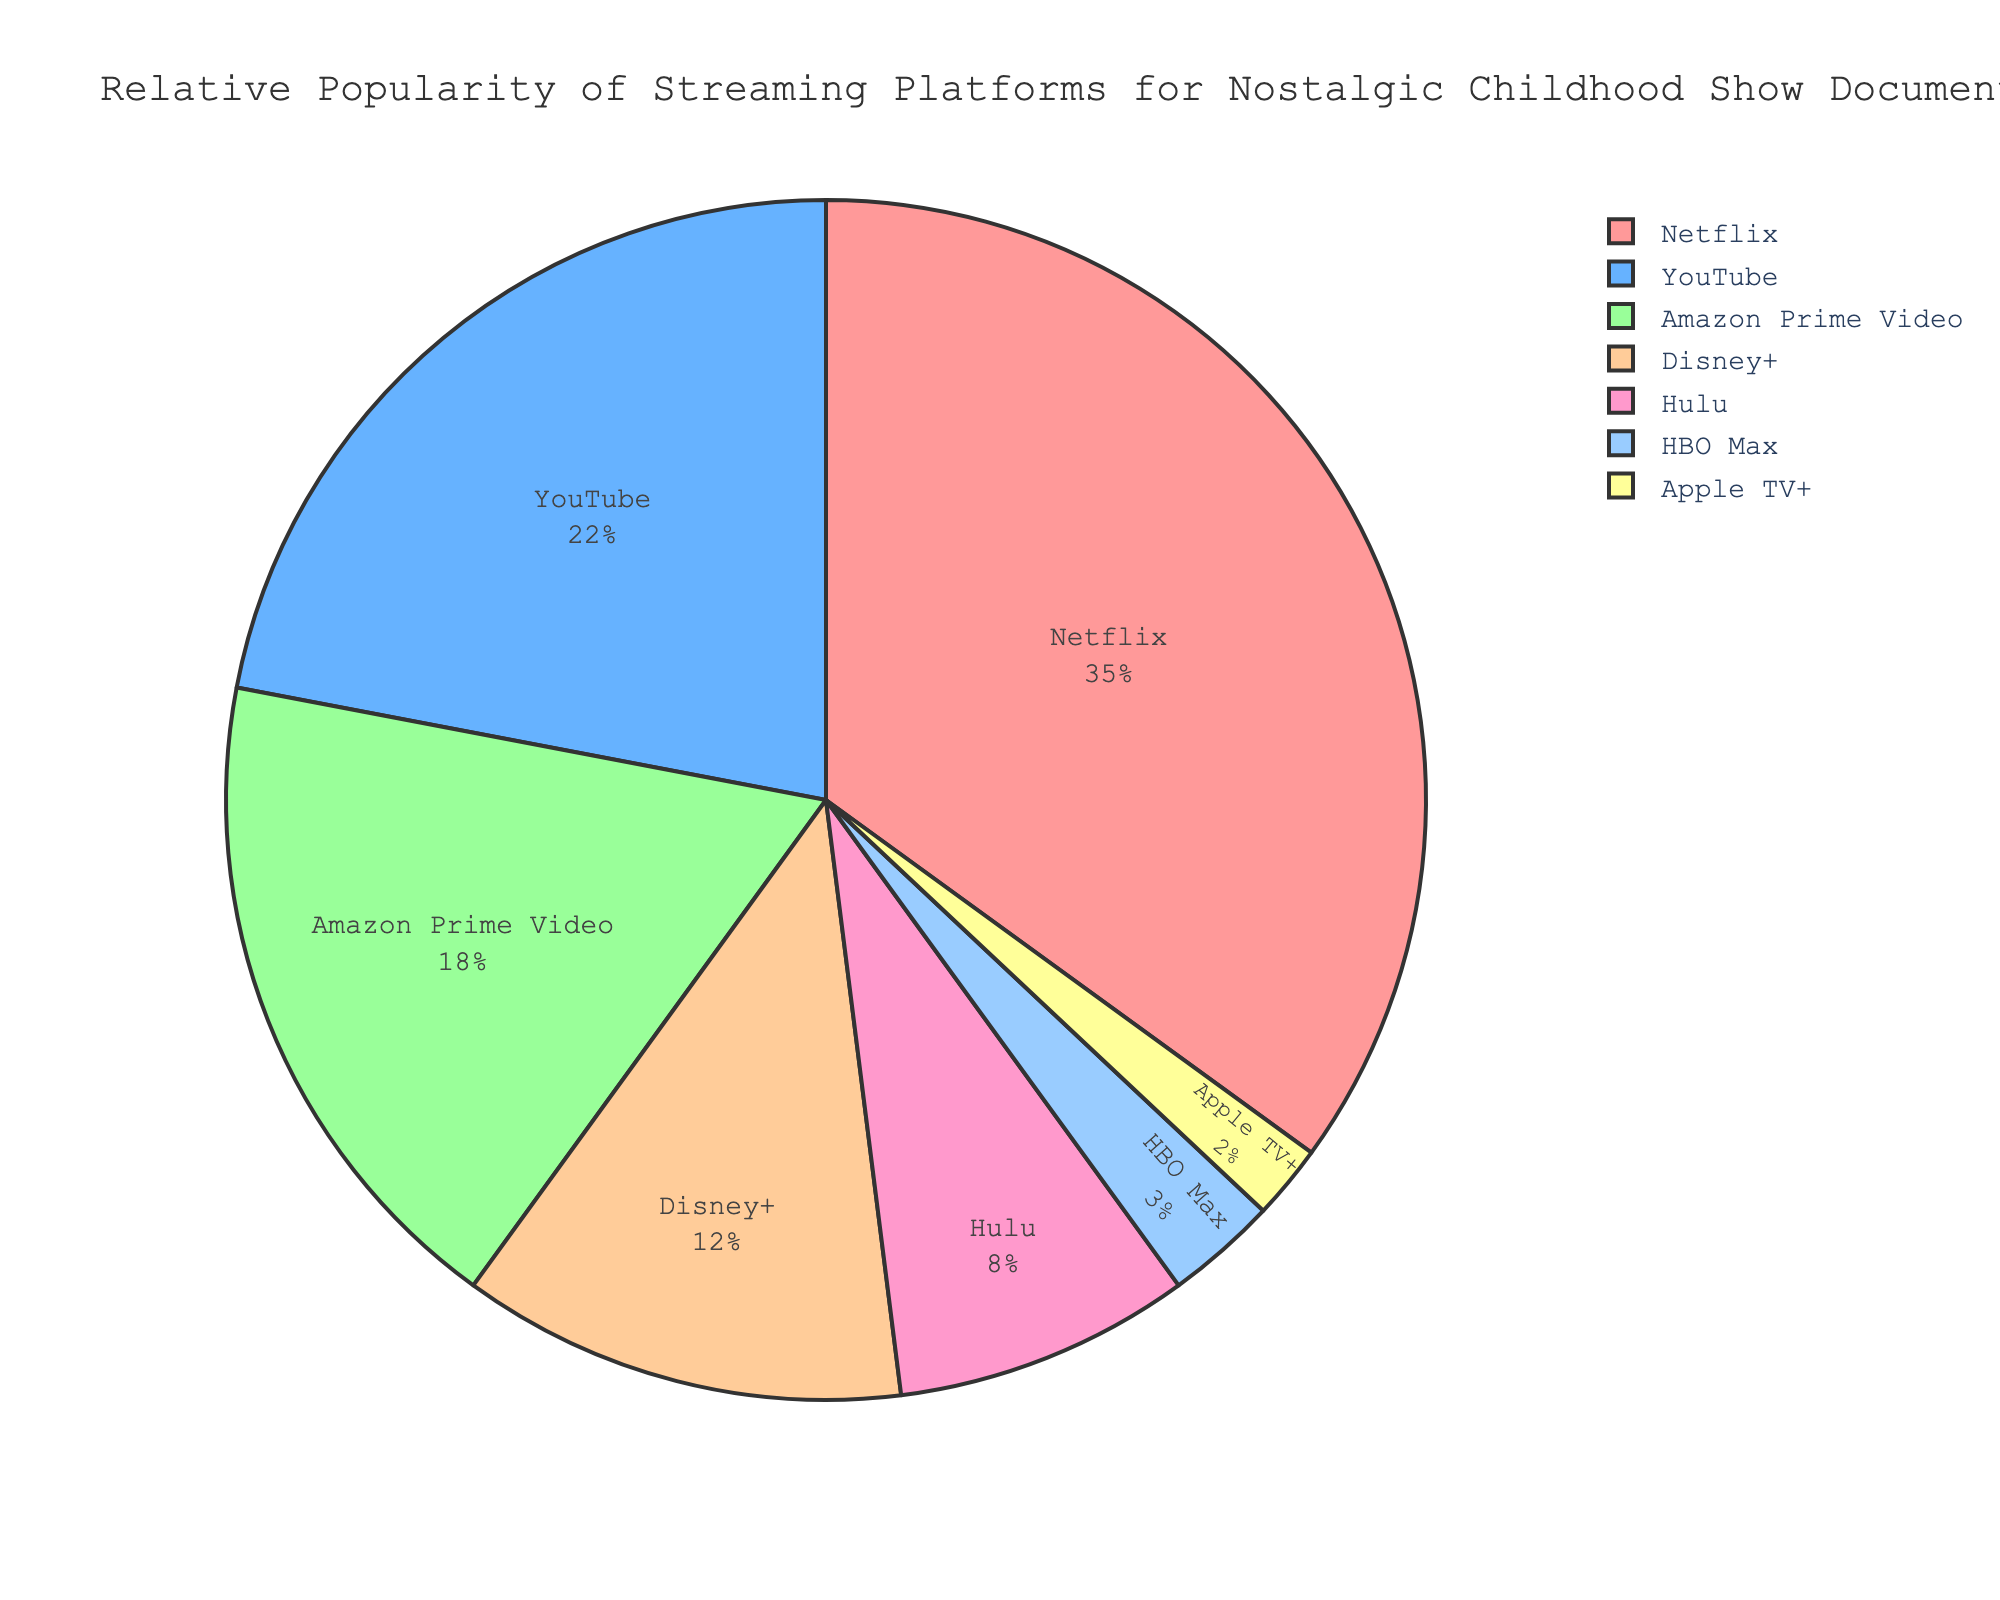What percentage of platforms other than Netflix host nostalgic childhood show documentaries? To find this, first identify the percentage that Netflix holds, which is 35%. Then subtract this percentage from 100%: 100% - 35% = 65%. Therefore, 65% of platforms other than Netflix host nostalgic childhood show documentaries
Answer: 65% Which platform hosts fewer nostalgic childhood show documentaries, HBO Max or Apple TV+? Refer to the chart to identify the percentages for each platform. HBO Max hosts 3%, while Apple TV+ hosts 2%. Since 2% is less than 3%, Apple TV+ hosts fewer nostalgic childhood show documentaries
Answer: Apple TV+ If you combine the percentages of YouTube and Amazon Prime Video, what is the total percentage? Look at the percentages for YouTube and Amazon Prime Video. YouTube holds 22%, and Amazon Prime Video holds 18%. Add these two percentages together: 22% + 18% = 40%
Answer: 40% How much more popular is Netflix compared to Disney+ for hosting nostalgic childhood show documentaries? Find the percentages for Netflix and Disney+. Netflix holds 35%, and Disney+ holds 12%. Subtract the percentage of Disney+ from Netflix: 35% - 12% = 23%. Therefore, Netflix is 23% more popular than Disney+ for this content
Answer: 23% Among the platforms listed, which one hosts the highest percentage of nostalgic childhood show documentaries? Refer to the chart to identify the platform with the highest percentage. Netflix holds 35%, which is the highest among all the platforms listed
Answer: Netflix What is the cumulative percentage for the three least popular platforms? Determine the percentages for the three least popular platforms: HBO Max (3%), Apple TV+ (2%), and Hulu (8%). Add these percentages together: 3% + 2% + 8% = 13%
Answer: 13% Is the combined share of Hulu and Disney+ greater than that of Netflix? Refer to the chart for individual percentages. Hulu (8%) and Disney+ (12%) together sum to 8% + 12% = 20%. Netflix holds 35%. Since 20% is less than 35%, the combined share of Hulu and Disney+ is not greater than that of Netflix
Answer: No Which color represents YouTube on the pie chart? Consult the chart and the corresponding legend to identify the color associated with YouTube. According to the custom color palette, YouTube is represented by a blue shade
Answer: Blue How many platforms have a percentage share less than 10%? Identify platforms with less than 10% share from the chart. Hulu (8%), HBO Max (3%), and Apple TV+ (2%) fall into this category. Therefore, there are 3 such platforms
Answer: 3 What is the percentage difference between the two platforms with the closest percentage shares? Identify the two platforms with the closest shares: Hulu (8%) and Disney+ (12%). Subtract the smaller percentage from the larger one: 12% - 8% = 4%. The percentage difference between these two platforms is 4%
Answer: 4% 